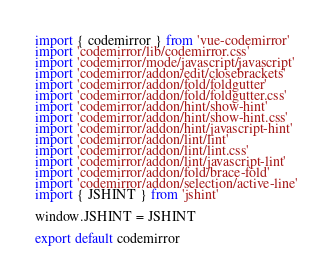Convert code to text. <code><loc_0><loc_0><loc_500><loc_500><_JavaScript_>import { codemirror } from 'vue-codemirror'
import 'codemirror/lib/codemirror.css'
import 'codemirror/mode/javascript/javascript'
import 'codemirror/addon/edit/closebrackets'
import 'codemirror/addon/fold/foldgutter'
import 'codemirror/addon/fold/foldgutter.css'
import 'codemirror/addon/hint/show-hint'
import 'codemirror/addon/hint/show-hint.css'
import 'codemirror/addon/hint/javascript-hint'
import 'codemirror/addon/lint/lint'
import 'codemirror/addon/lint/lint.css'
import 'codemirror/addon/lint/javascript-lint'
import 'codemirror/addon/fold/brace-fold'
import 'codemirror/addon/selection/active-line'
import { JSHINT } from 'jshint'

window.JSHINT = JSHINT

export default codemirror
</code> 